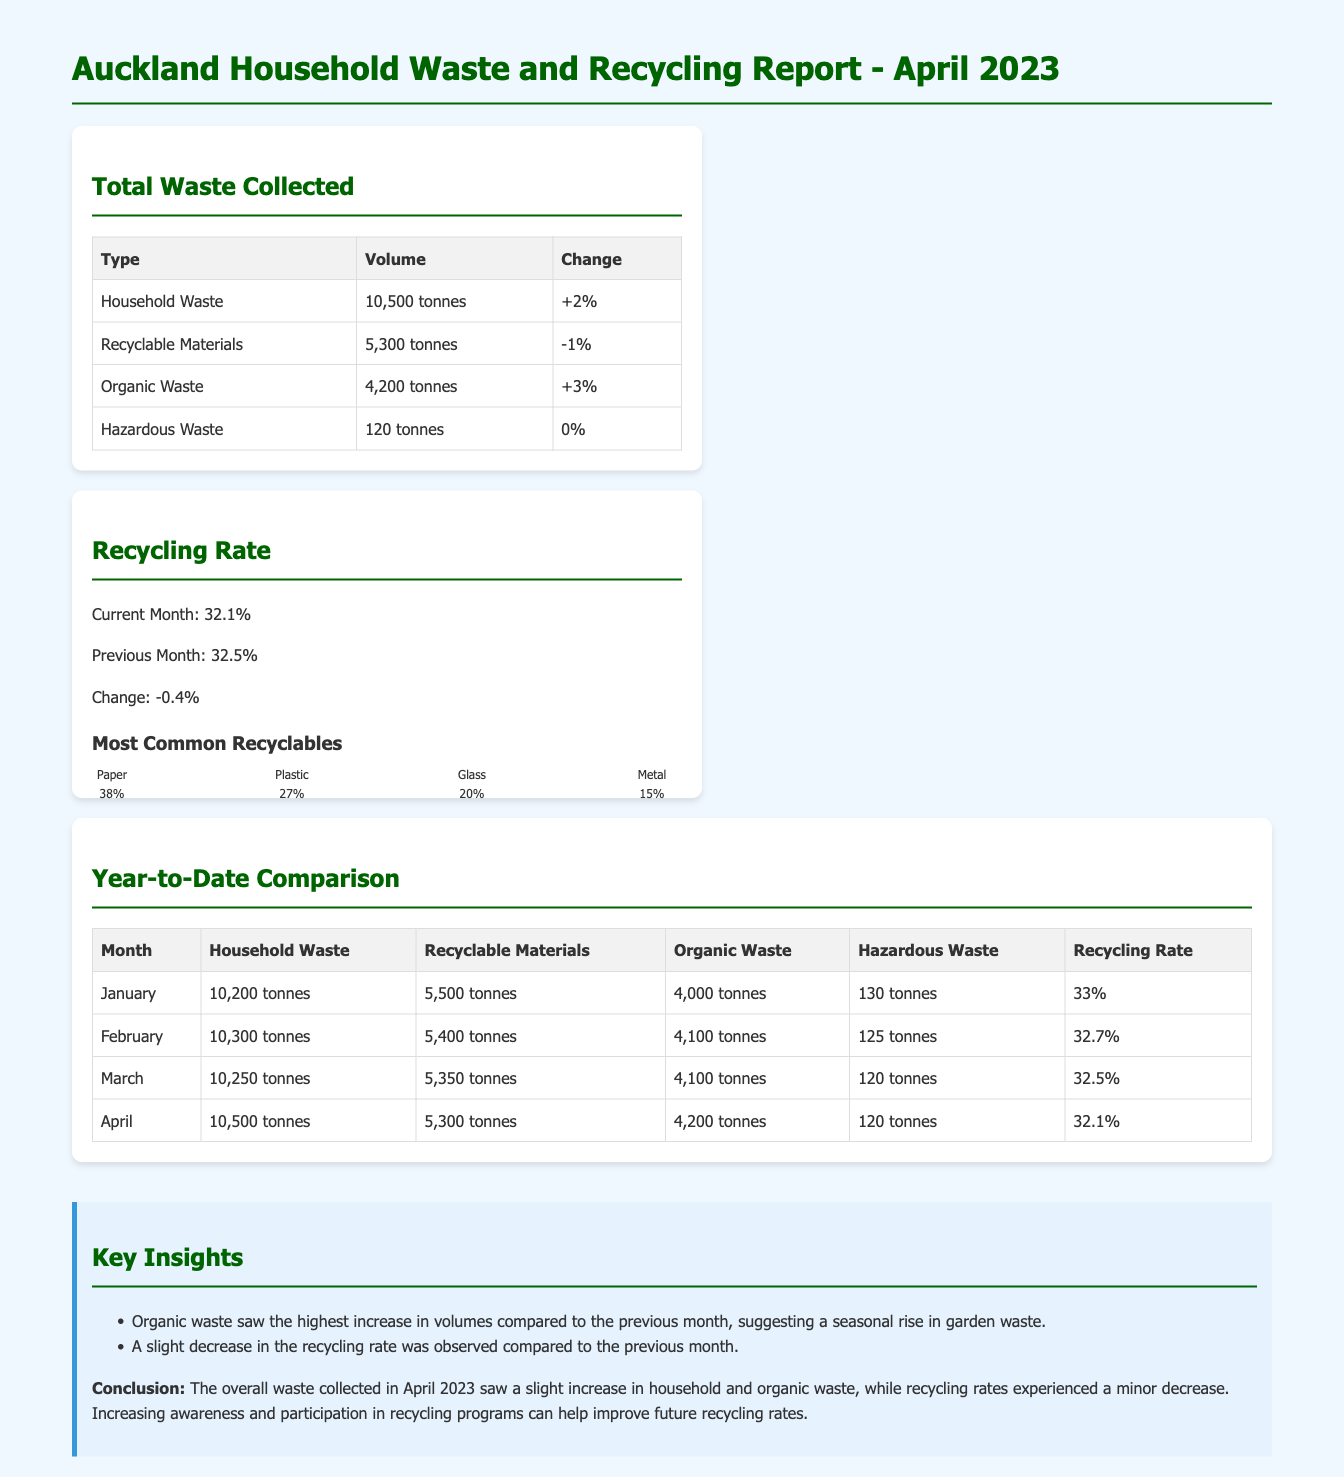What was the total volume of household waste collected in April 2023? The total volume of household waste collected in April 2023 is stated in the report as 10,500 tonnes.
Answer: 10,500 tonnes What was the recycling rate in March 2023? The recycling rate for March 2023 can be found in the year-to-date comparison table; it is listed as 32.5%.
Answer: 32.5% Which type of waste saw the highest increase in volume compared to the previous month? According to the key insights, organic waste had the highest increase in volumes, indicating a seasonal rise.
Answer: Organic Waste What is the change in the volume of recyclable materials in April 2023? The document specifies a decrease of 1% in the volume of recyclable materials compared to the previous month.
Answer: -1% What percentage of recyclables in April 2023 was paper? The chart for the most common recyclables indicates that paper made up 38% of the recyclables.
Answer: 38% How much hazardous waste was collected in April 2023? The amount of hazardous waste collected in April 2023 is reported as 120 tonnes.
Answer: 120 tonnes What is the overall change in the recycling rate from March to April 2023? The document shows that the recycling rate decreased by 0.4% from March to April 2023.
Answer: -0.4% What was the volume of organic waste collected in April 2023? The report indicates that organic waste collected in April 2023 amounted to 4,200 tonnes.
Answer: 4,200 tonnes What is the total volume of waste collected (household, recyclable, organic, hazardous) in April 2023? The total waste can be calculated by adding all types listed in the total waste collected section: Household (10,500) + Recyclable (5,300) + Organic (4,200) + Hazardous (120) = 20,120 tonnes.
Answer: 20,120 tonnes 